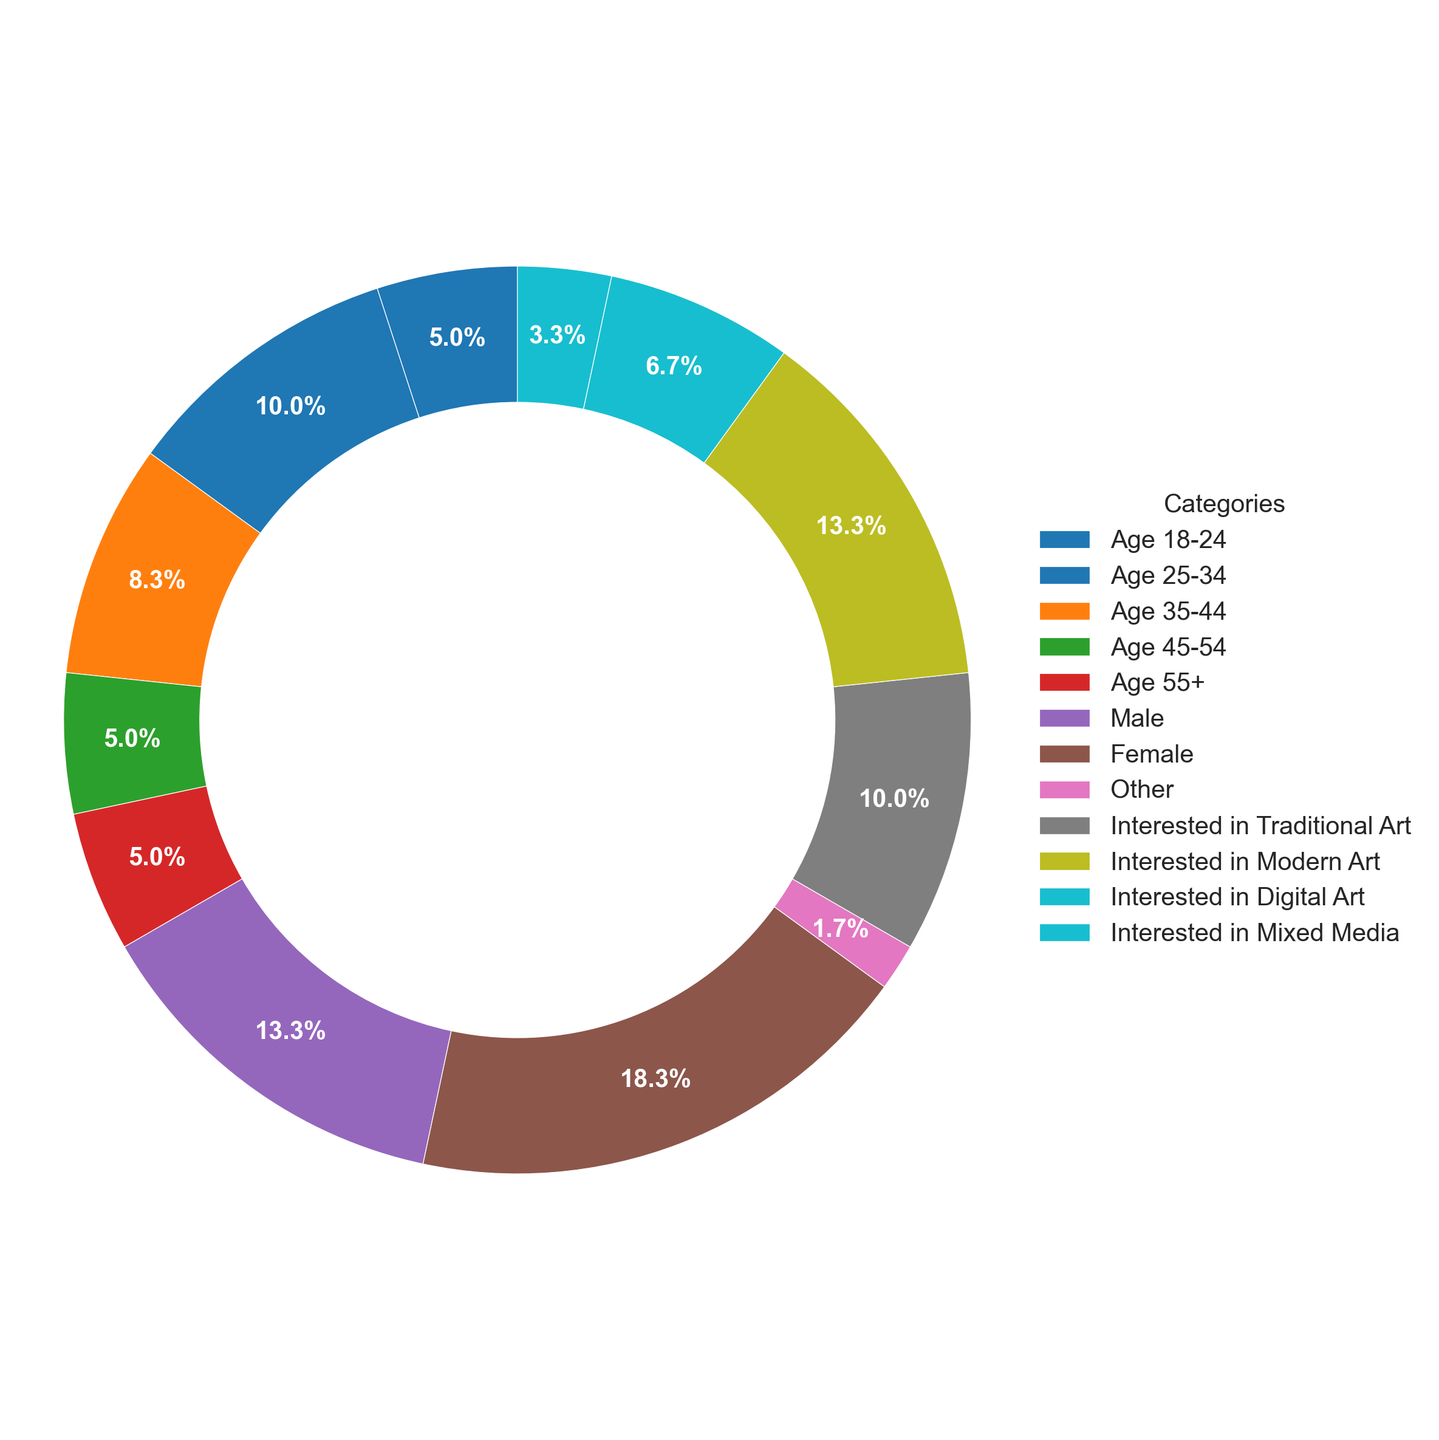Which age group represents the largest segment of the audience? By referring to the figure, we can see that the Age 25-34 group has the largest slice of the ring chart, indicating it has the highest percentage.
Answer: Age 25-34 How much larger is the "Female" segment compared to the "Male" segment? The Female segment is 55% while the Male segment is 40%. The difference between them is calculated as 55% - 40%.
Answer: 15% Which art interest category has the smallest audience? By examining the ring chart, we can see that the smallest slice belongs to the "Interested in Mixed Media" category, indicating it has the smallest percentage.
Answer: Interested in Mixed Media What is the combined percentage of the audience aged 18-24 and 45-54? The figure shows that Age 18-24 is 15% and Age 45-54 is also 15%. Adding these together gives 15% + 15%.
Answer: 30% How does the percentage of people interested in Digital Art compare to those interested in Traditional Art? The chart shows that 20% are interested in Digital Art and 30% are interested in Traditional Art. By comparing these, we see that interest in Traditional Art is higher by 10%.
Answer: Traditional Art is higher by 10% If you combined the percentages of Age 25-34 and Age 35-44, would that segment make up a majority of the audience? The segment Age 25-34 is 30% and Age 35-44 is 25%. Adding these gives 30% + 25%, which totals 55%, more than half of the audience.
Answer: Yes, 55% How does the "Other" gender segment compare visually to the other segments? The "Other" gender segment has a visibly smaller slice at 5% compared to the larger segments "Male" at 40% and "Female" at 55%.
Answer: It is much smaller Which interest category in art has the largest representation? The ring chart indicates that the largest slice is for those who are Interested in Modern Art, with a percentage of 40%.
Answer: Modern Art How many times larger is the interest in Modern Art compared to Mixed Media? Interest in Modern Art is 40% while interest in Mixed Media is 10%. Dividing the larger percentage by the smaller one, 40% / 10%, gives 4 times larger.
Answer: 4 times Among the age groups 45-54 and 55+, which has more representation in the audience? Both the Age 45-54 and Age 55+ groups represent 15% each, hence they have equal representation.
Answer: They are equal 